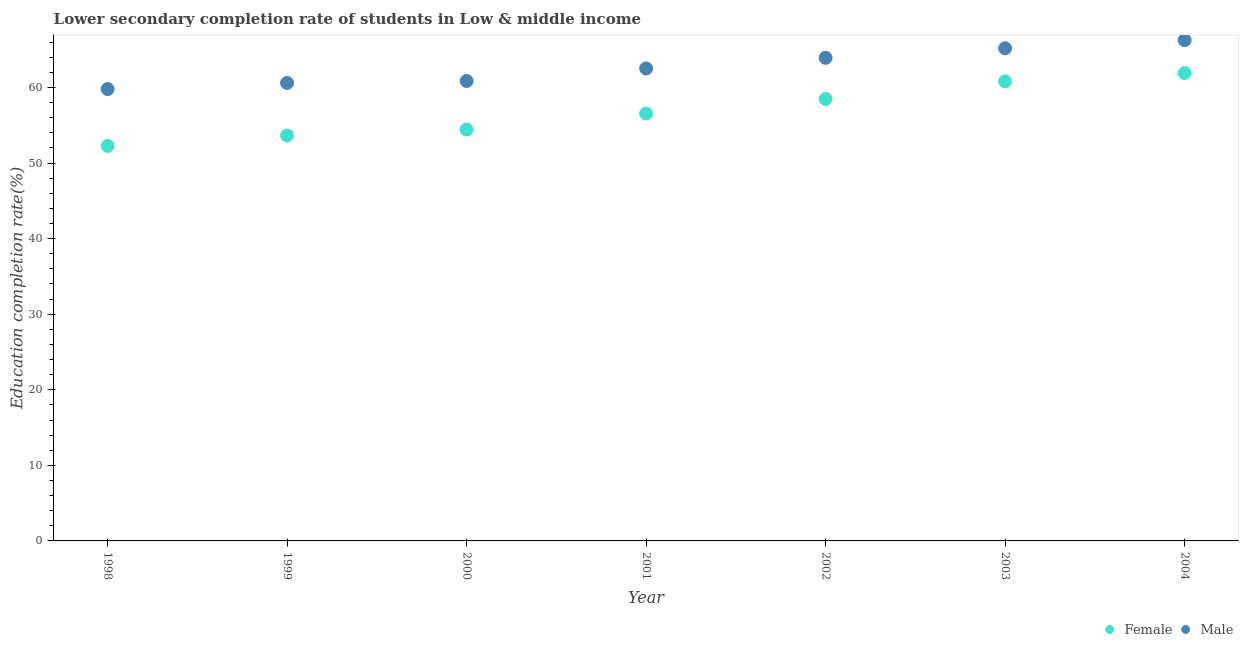Is the number of dotlines equal to the number of legend labels?
Provide a short and direct response. Yes. What is the education completion rate of female students in 2001?
Make the answer very short. 56.56. Across all years, what is the maximum education completion rate of male students?
Provide a succinct answer. 66.27. Across all years, what is the minimum education completion rate of male students?
Provide a short and direct response. 59.8. What is the total education completion rate of female students in the graph?
Make the answer very short. 398.13. What is the difference between the education completion rate of female students in 1999 and that in 2000?
Offer a very short reply. -0.79. What is the difference between the education completion rate of female students in 1999 and the education completion rate of male students in 2004?
Ensure brevity in your answer.  -12.62. What is the average education completion rate of male students per year?
Offer a very short reply. 62.74. In the year 2004, what is the difference between the education completion rate of female students and education completion rate of male students?
Provide a succinct answer. -4.35. What is the ratio of the education completion rate of female students in 2003 to that in 2004?
Your answer should be compact. 0.98. Is the education completion rate of male students in 2001 less than that in 2002?
Provide a short and direct response. Yes. Is the difference between the education completion rate of female students in 1998 and 2001 greater than the difference between the education completion rate of male students in 1998 and 2001?
Your response must be concise. No. What is the difference between the highest and the second highest education completion rate of male students?
Your response must be concise. 1.07. What is the difference between the highest and the lowest education completion rate of male students?
Your answer should be very brief. 6.47. Does the education completion rate of male students monotonically increase over the years?
Make the answer very short. Yes. Is the education completion rate of female students strictly less than the education completion rate of male students over the years?
Your response must be concise. Yes. What is the difference between two consecutive major ticks on the Y-axis?
Give a very brief answer. 10. Does the graph contain any zero values?
Offer a very short reply. No. Does the graph contain grids?
Ensure brevity in your answer.  No. How many legend labels are there?
Your answer should be compact. 2. What is the title of the graph?
Give a very brief answer. Lower secondary completion rate of students in Low & middle income. Does "Total Population" appear as one of the legend labels in the graph?
Keep it short and to the point. No. What is the label or title of the X-axis?
Your response must be concise. Year. What is the label or title of the Y-axis?
Make the answer very short. Education completion rate(%). What is the Education completion rate(%) in Female in 1998?
Your answer should be very brief. 52.27. What is the Education completion rate(%) of Male in 1998?
Make the answer very short. 59.8. What is the Education completion rate(%) of Female in 1999?
Keep it short and to the point. 53.65. What is the Education completion rate(%) in Male in 1999?
Your answer should be very brief. 60.6. What is the Education completion rate(%) of Female in 2000?
Ensure brevity in your answer.  54.44. What is the Education completion rate(%) of Male in 2000?
Your answer should be compact. 60.87. What is the Education completion rate(%) of Female in 2001?
Provide a succinct answer. 56.56. What is the Education completion rate(%) in Male in 2001?
Give a very brief answer. 62.53. What is the Education completion rate(%) in Female in 2002?
Provide a succinct answer. 58.48. What is the Education completion rate(%) in Male in 2002?
Provide a succinct answer. 63.93. What is the Education completion rate(%) in Female in 2003?
Make the answer very short. 60.81. What is the Education completion rate(%) of Male in 2003?
Provide a short and direct response. 65.2. What is the Education completion rate(%) of Female in 2004?
Offer a terse response. 61.92. What is the Education completion rate(%) in Male in 2004?
Provide a short and direct response. 66.27. Across all years, what is the maximum Education completion rate(%) of Female?
Give a very brief answer. 61.92. Across all years, what is the maximum Education completion rate(%) in Male?
Your answer should be very brief. 66.27. Across all years, what is the minimum Education completion rate(%) in Female?
Offer a very short reply. 52.27. Across all years, what is the minimum Education completion rate(%) in Male?
Give a very brief answer. 59.8. What is the total Education completion rate(%) in Female in the graph?
Keep it short and to the point. 398.13. What is the total Education completion rate(%) in Male in the graph?
Provide a short and direct response. 439.18. What is the difference between the Education completion rate(%) of Female in 1998 and that in 1999?
Your answer should be compact. -1.38. What is the difference between the Education completion rate(%) of Male in 1998 and that in 1999?
Ensure brevity in your answer.  -0.81. What is the difference between the Education completion rate(%) of Female in 1998 and that in 2000?
Keep it short and to the point. -2.18. What is the difference between the Education completion rate(%) in Male in 1998 and that in 2000?
Provide a short and direct response. -1.07. What is the difference between the Education completion rate(%) in Female in 1998 and that in 2001?
Your answer should be very brief. -4.29. What is the difference between the Education completion rate(%) in Male in 1998 and that in 2001?
Your response must be concise. -2.73. What is the difference between the Education completion rate(%) of Female in 1998 and that in 2002?
Your answer should be very brief. -6.21. What is the difference between the Education completion rate(%) in Male in 1998 and that in 2002?
Your answer should be compact. -4.13. What is the difference between the Education completion rate(%) of Female in 1998 and that in 2003?
Provide a short and direct response. -8.54. What is the difference between the Education completion rate(%) in Male in 1998 and that in 2003?
Make the answer very short. -5.4. What is the difference between the Education completion rate(%) in Female in 1998 and that in 2004?
Offer a terse response. -9.65. What is the difference between the Education completion rate(%) of Male in 1998 and that in 2004?
Ensure brevity in your answer.  -6.47. What is the difference between the Education completion rate(%) in Female in 1999 and that in 2000?
Offer a very short reply. -0.79. What is the difference between the Education completion rate(%) in Male in 1999 and that in 2000?
Provide a succinct answer. -0.26. What is the difference between the Education completion rate(%) in Female in 1999 and that in 2001?
Ensure brevity in your answer.  -2.91. What is the difference between the Education completion rate(%) of Male in 1999 and that in 2001?
Give a very brief answer. -1.92. What is the difference between the Education completion rate(%) in Female in 1999 and that in 2002?
Ensure brevity in your answer.  -4.83. What is the difference between the Education completion rate(%) in Male in 1999 and that in 2002?
Provide a short and direct response. -3.33. What is the difference between the Education completion rate(%) of Female in 1999 and that in 2003?
Give a very brief answer. -7.16. What is the difference between the Education completion rate(%) in Male in 1999 and that in 2003?
Your response must be concise. -4.59. What is the difference between the Education completion rate(%) in Female in 1999 and that in 2004?
Provide a short and direct response. -8.27. What is the difference between the Education completion rate(%) of Male in 1999 and that in 2004?
Provide a short and direct response. -5.66. What is the difference between the Education completion rate(%) of Female in 2000 and that in 2001?
Offer a very short reply. -2.12. What is the difference between the Education completion rate(%) of Male in 2000 and that in 2001?
Your answer should be very brief. -1.66. What is the difference between the Education completion rate(%) in Female in 2000 and that in 2002?
Provide a short and direct response. -4.04. What is the difference between the Education completion rate(%) of Male in 2000 and that in 2002?
Provide a short and direct response. -3.06. What is the difference between the Education completion rate(%) of Female in 2000 and that in 2003?
Offer a terse response. -6.37. What is the difference between the Education completion rate(%) in Male in 2000 and that in 2003?
Keep it short and to the point. -4.33. What is the difference between the Education completion rate(%) in Female in 2000 and that in 2004?
Give a very brief answer. -7.48. What is the difference between the Education completion rate(%) of Male in 2000 and that in 2004?
Offer a terse response. -5.4. What is the difference between the Education completion rate(%) of Female in 2001 and that in 2002?
Make the answer very short. -1.92. What is the difference between the Education completion rate(%) of Male in 2001 and that in 2002?
Ensure brevity in your answer.  -1.4. What is the difference between the Education completion rate(%) in Female in 2001 and that in 2003?
Ensure brevity in your answer.  -4.25. What is the difference between the Education completion rate(%) in Male in 2001 and that in 2003?
Offer a terse response. -2.67. What is the difference between the Education completion rate(%) in Female in 2001 and that in 2004?
Ensure brevity in your answer.  -5.36. What is the difference between the Education completion rate(%) in Male in 2001 and that in 2004?
Offer a very short reply. -3.74. What is the difference between the Education completion rate(%) of Female in 2002 and that in 2003?
Offer a terse response. -2.33. What is the difference between the Education completion rate(%) in Male in 2002 and that in 2003?
Offer a very short reply. -1.27. What is the difference between the Education completion rate(%) of Female in 2002 and that in 2004?
Your response must be concise. -3.44. What is the difference between the Education completion rate(%) in Male in 2002 and that in 2004?
Offer a very short reply. -2.34. What is the difference between the Education completion rate(%) in Female in 2003 and that in 2004?
Give a very brief answer. -1.11. What is the difference between the Education completion rate(%) in Male in 2003 and that in 2004?
Offer a terse response. -1.07. What is the difference between the Education completion rate(%) in Female in 1998 and the Education completion rate(%) in Male in 1999?
Your answer should be compact. -8.34. What is the difference between the Education completion rate(%) in Female in 1998 and the Education completion rate(%) in Male in 2000?
Ensure brevity in your answer.  -8.6. What is the difference between the Education completion rate(%) of Female in 1998 and the Education completion rate(%) of Male in 2001?
Ensure brevity in your answer.  -10.26. What is the difference between the Education completion rate(%) of Female in 1998 and the Education completion rate(%) of Male in 2002?
Give a very brief answer. -11.66. What is the difference between the Education completion rate(%) of Female in 1998 and the Education completion rate(%) of Male in 2003?
Make the answer very short. -12.93. What is the difference between the Education completion rate(%) in Female in 1998 and the Education completion rate(%) in Male in 2004?
Your response must be concise. -14. What is the difference between the Education completion rate(%) in Female in 1999 and the Education completion rate(%) in Male in 2000?
Offer a terse response. -7.22. What is the difference between the Education completion rate(%) of Female in 1999 and the Education completion rate(%) of Male in 2001?
Give a very brief answer. -8.88. What is the difference between the Education completion rate(%) of Female in 1999 and the Education completion rate(%) of Male in 2002?
Provide a short and direct response. -10.28. What is the difference between the Education completion rate(%) of Female in 1999 and the Education completion rate(%) of Male in 2003?
Your answer should be very brief. -11.54. What is the difference between the Education completion rate(%) in Female in 1999 and the Education completion rate(%) in Male in 2004?
Ensure brevity in your answer.  -12.62. What is the difference between the Education completion rate(%) of Female in 2000 and the Education completion rate(%) of Male in 2001?
Offer a very short reply. -8.09. What is the difference between the Education completion rate(%) in Female in 2000 and the Education completion rate(%) in Male in 2002?
Your answer should be very brief. -9.49. What is the difference between the Education completion rate(%) of Female in 2000 and the Education completion rate(%) of Male in 2003?
Ensure brevity in your answer.  -10.75. What is the difference between the Education completion rate(%) in Female in 2000 and the Education completion rate(%) in Male in 2004?
Keep it short and to the point. -11.83. What is the difference between the Education completion rate(%) in Female in 2001 and the Education completion rate(%) in Male in 2002?
Give a very brief answer. -7.37. What is the difference between the Education completion rate(%) of Female in 2001 and the Education completion rate(%) of Male in 2003?
Your response must be concise. -8.63. What is the difference between the Education completion rate(%) of Female in 2001 and the Education completion rate(%) of Male in 2004?
Provide a short and direct response. -9.71. What is the difference between the Education completion rate(%) in Female in 2002 and the Education completion rate(%) in Male in 2003?
Ensure brevity in your answer.  -6.72. What is the difference between the Education completion rate(%) in Female in 2002 and the Education completion rate(%) in Male in 2004?
Provide a succinct answer. -7.79. What is the difference between the Education completion rate(%) in Female in 2003 and the Education completion rate(%) in Male in 2004?
Ensure brevity in your answer.  -5.46. What is the average Education completion rate(%) in Female per year?
Your answer should be very brief. 56.88. What is the average Education completion rate(%) of Male per year?
Your answer should be compact. 62.74. In the year 1998, what is the difference between the Education completion rate(%) of Female and Education completion rate(%) of Male?
Give a very brief answer. -7.53. In the year 1999, what is the difference between the Education completion rate(%) of Female and Education completion rate(%) of Male?
Ensure brevity in your answer.  -6.95. In the year 2000, what is the difference between the Education completion rate(%) in Female and Education completion rate(%) in Male?
Give a very brief answer. -6.43. In the year 2001, what is the difference between the Education completion rate(%) in Female and Education completion rate(%) in Male?
Provide a succinct answer. -5.97. In the year 2002, what is the difference between the Education completion rate(%) in Female and Education completion rate(%) in Male?
Your answer should be compact. -5.45. In the year 2003, what is the difference between the Education completion rate(%) of Female and Education completion rate(%) of Male?
Provide a short and direct response. -4.38. In the year 2004, what is the difference between the Education completion rate(%) in Female and Education completion rate(%) in Male?
Provide a short and direct response. -4.35. What is the ratio of the Education completion rate(%) of Female in 1998 to that in 1999?
Offer a very short reply. 0.97. What is the ratio of the Education completion rate(%) in Male in 1998 to that in 1999?
Give a very brief answer. 0.99. What is the ratio of the Education completion rate(%) of Female in 1998 to that in 2000?
Offer a terse response. 0.96. What is the ratio of the Education completion rate(%) in Male in 1998 to that in 2000?
Keep it short and to the point. 0.98. What is the ratio of the Education completion rate(%) of Female in 1998 to that in 2001?
Provide a short and direct response. 0.92. What is the ratio of the Education completion rate(%) of Male in 1998 to that in 2001?
Your answer should be compact. 0.96. What is the ratio of the Education completion rate(%) in Female in 1998 to that in 2002?
Your answer should be very brief. 0.89. What is the ratio of the Education completion rate(%) of Male in 1998 to that in 2002?
Offer a very short reply. 0.94. What is the ratio of the Education completion rate(%) in Female in 1998 to that in 2003?
Give a very brief answer. 0.86. What is the ratio of the Education completion rate(%) in Male in 1998 to that in 2003?
Your answer should be compact. 0.92. What is the ratio of the Education completion rate(%) of Female in 1998 to that in 2004?
Your response must be concise. 0.84. What is the ratio of the Education completion rate(%) of Male in 1998 to that in 2004?
Provide a short and direct response. 0.9. What is the ratio of the Education completion rate(%) of Female in 1999 to that in 2000?
Provide a short and direct response. 0.99. What is the ratio of the Education completion rate(%) in Male in 1999 to that in 2000?
Keep it short and to the point. 1. What is the ratio of the Education completion rate(%) of Female in 1999 to that in 2001?
Your response must be concise. 0.95. What is the ratio of the Education completion rate(%) in Male in 1999 to that in 2001?
Your response must be concise. 0.97. What is the ratio of the Education completion rate(%) in Female in 1999 to that in 2002?
Make the answer very short. 0.92. What is the ratio of the Education completion rate(%) of Male in 1999 to that in 2002?
Make the answer very short. 0.95. What is the ratio of the Education completion rate(%) of Female in 1999 to that in 2003?
Your response must be concise. 0.88. What is the ratio of the Education completion rate(%) in Male in 1999 to that in 2003?
Offer a terse response. 0.93. What is the ratio of the Education completion rate(%) of Female in 1999 to that in 2004?
Give a very brief answer. 0.87. What is the ratio of the Education completion rate(%) in Male in 1999 to that in 2004?
Give a very brief answer. 0.91. What is the ratio of the Education completion rate(%) of Female in 2000 to that in 2001?
Give a very brief answer. 0.96. What is the ratio of the Education completion rate(%) in Male in 2000 to that in 2001?
Your answer should be very brief. 0.97. What is the ratio of the Education completion rate(%) in Female in 2000 to that in 2002?
Provide a succinct answer. 0.93. What is the ratio of the Education completion rate(%) in Male in 2000 to that in 2002?
Make the answer very short. 0.95. What is the ratio of the Education completion rate(%) of Female in 2000 to that in 2003?
Offer a terse response. 0.9. What is the ratio of the Education completion rate(%) of Male in 2000 to that in 2003?
Your answer should be compact. 0.93. What is the ratio of the Education completion rate(%) in Female in 2000 to that in 2004?
Provide a short and direct response. 0.88. What is the ratio of the Education completion rate(%) in Male in 2000 to that in 2004?
Provide a succinct answer. 0.92. What is the ratio of the Education completion rate(%) in Female in 2001 to that in 2002?
Offer a very short reply. 0.97. What is the ratio of the Education completion rate(%) of Female in 2001 to that in 2003?
Give a very brief answer. 0.93. What is the ratio of the Education completion rate(%) of Male in 2001 to that in 2003?
Make the answer very short. 0.96. What is the ratio of the Education completion rate(%) of Female in 2001 to that in 2004?
Offer a terse response. 0.91. What is the ratio of the Education completion rate(%) of Male in 2001 to that in 2004?
Provide a short and direct response. 0.94. What is the ratio of the Education completion rate(%) in Female in 2002 to that in 2003?
Ensure brevity in your answer.  0.96. What is the ratio of the Education completion rate(%) in Male in 2002 to that in 2003?
Your answer should be very brief. 0.98. What is the ratio of the Education completion rate(%) of Female in 2002 to that in 2004?
Keep it short and to the point. 0.94. What is the ratio of the Education completion rate(%) in Male in 2002 to that in 2004?
Offer a terse response. 0.96. What is the ratio of the Education completion rate(%) in Female in 2003 to that in 2004?
Make the answer very short. 0.98. What is the ratio of the Education completion rate(%) of Male in 2003 to that in 2004?
Offer a very short reply. 0.98. What is the difference between the highest and the second highest Education completion rate(%) in Female?
Keep it short and to the point. 1.11. What is the difference between the highest and the second highest Education completion rate(%) in Male?
Offer a terse response. 1.07. What is the difference between the highest and the lowest Education completion rate(%) of Female?
Your response must be concise. 9.65. What is the difference between the highest and the lowest Education completion rate(%) of Male?
Make the answer very short. 6.47. 